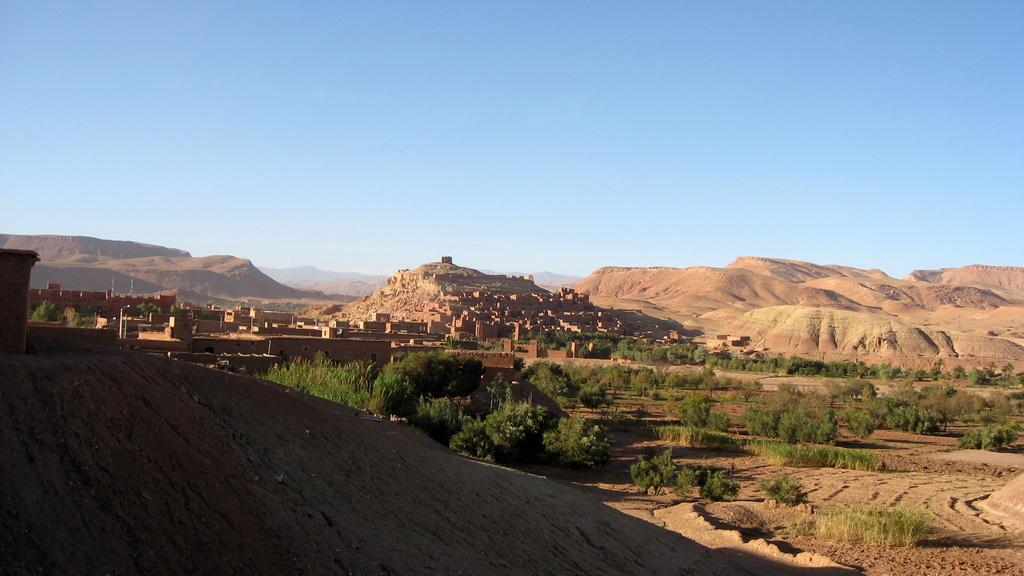What type of structures can be seen in the image? There are houses in the image. What else is present in the image besides houses? There is greenery in the image. Can you describe the central area of the image? The center of the image contains houses and greenery. What is the texture of the ground in the image? There is a muddy texture in the image. What month is it in the image? The month cannot be determined from the image, as there is no information about the time of year. Are there any cattle or beasts present in the image? There are no cattle or beasts visible in the image; it primarily features houses and greenery. 